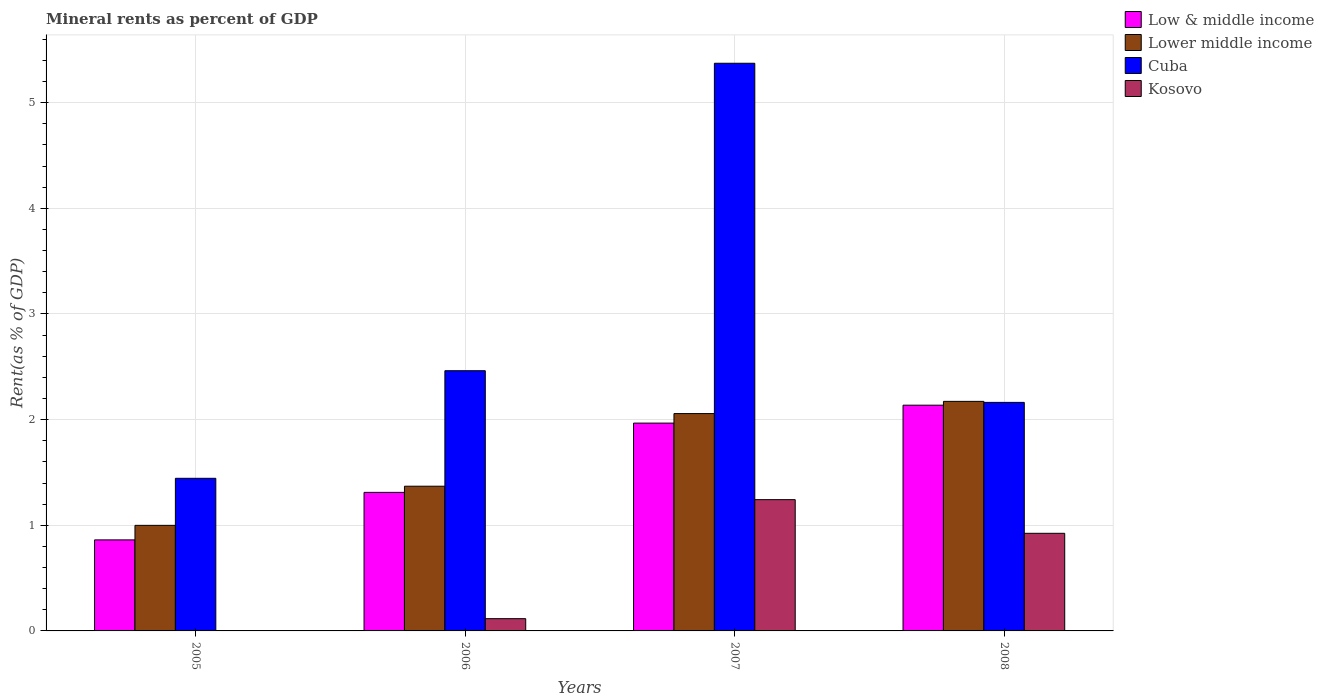How many different coloured bars are there?
Keep it short and to the point. 4. How many groups of bars are there?
Your response must be concise. 4. Are the number of bars per tick equal to the number of legend labels?
Provide a succinct answer. Yes. How many bars are there on the 3rd tick from the right?
Give a very brief answer. 4. What is the label of the 4th group of bars from the left?
Provide a succinct answer. 2008. What is the mineral rent in Lower middle income in 2008?
Keep it short and to the point. 2.17. Across all years, what is the maximum mineral rent in Low & middle income?
Keep it short and to the point. 2.14. Across all years, what is the minimum mineral rent in Low & middle income?
Offer a terse response. 0.86. In which year was the mineral rent in Low & middle income minimum?
Provide a succinct answer. 2005. What is the total mineral rent in Cuba in the graph?
Ensure brevity in your answer.  11.44. What is the difference between the mineral rent in Cuba in 2007 and that in 2008?
Give a very brief answer. 3.21. What is the difference between the mineral rent in Cuba in 2007 and the mineral rent in Lower middle income in 2006?
Offer a very short reply. 4. What is the average mineral rent in Kosovo per year?
Make the answer very short. 0.57. In the year 2006, what is the difference between the mineral rent in Lower middle income and mineral rent in Cuba?
Offer a terse response. -1.09. What is the ratio of the mineral rent in Kosovo in 2007 to that in 2008?
Offer a very short reply. 1.34. Is the mineral rent in Cuba in 2005 less than that in 2006?
Offer a terse response. Yes. What is the difference between the highest and the second highest mineral rent in Low & middle income?
Your answer should be very brief. 0.17. What is the difference between the highest and the lowest mineral rent in Low & middle income?
Your answer should be compact. 1.28. What does the 3rd bar from the left in 2005 represents?
Your answer should be very brief. Cuba. What does the 2nd bar from the right in 2006 represents?
Your answer should be very brief. Cuba. Are all the bars in the graph horizontal?
Ensure brevity in your answer.  No. What is the difference between two consecutive major ticks on the Y-axis?
Give a very brief answer. 1. Does the graph contain any zero values?
Your answer should be compact. No. Does the graph contain grids?
Keep it short and to the point. Yes. What is the title of the graph?
Offer a terse response. Mineral rents as percent of GDP. What is the label or title of the Y-axis?
Provide a succinct answer. Rent(as % of GDP). What is the Rent(as % of GDP) of Low & middle income in 2005?
Give a very brief answer. 0.86. What is the Rent(as % of GDP) of Lower middle income in 2005?
Make the answer very short. 1. What is the Rent(as % of GDP) in Cuba in 2005?
Keep it short and to the point. 1.44. What is the Rent(as % of GDP) of Kosovo in 2005?
Provide a succinct answer. 0. What is the Rent(as % of GDP) of Low & middle income in 2006?
Offer a very short reply. 1.31. What is the Rent(as % of GDP) in Lower middle income in 2006?
Ensure brevity in your answer.  1.37. What is the Rent(as % of GDP) in Cuba in 2006?
Offer a terse response. 2.46. What is the Rent(as % of GDP) in Kosovo in 2006?
Your answer should be compact. 0.12. What is the Rent(as % of GDP) of Low & middle income in 2007?
Keep it short and to the point. 1.97. What is the Rent(as % of GDP) of Lower middle income in 2007?
Make the answer very short. 2.06. What is the Rent(as % of GDP) of Cuba in 2007?
Provide a short and direct response. 5.37. What is the Rent(as % of GDP) of Kosovo in 2007?
Keep it short and to the point. 1.24. What is the Rent(as % of GDP) in Low & middle income in 2008?
Keep it short and to the point. 2.14. What is the Rent(as % of GDP) in Lower middle income in 2008?
Provide a succinct answer. 2.17. What is the Rent(as % of GDP) of Cuba in 2008?
Your answer should be very brief. 2.16. What is the Rent(as % of GDP) of Kosovo in 2008?
Make the answer very short. 0.92. Across all years, what is the maximum Rent(as % of GDP) in Low & middle income?
Your answer should be very brief. 2.14. Across all years, what is the maximum Rent(as % of GDP) in Lower middle income?
Your answer should be very brief. 2.17. Across all years, what is the maximum Rent(as % of GDP) of Cuba?
Provide a succinct answer. 5.37. Across all years, what is the maximum Rent(as % of GDP) of Kosovo?
Keep it short and to the point. 1.24. Across all years, what is the minimum Rent(as % of GDP) of Low & middle income?
Give a very brief answer. 0.86. Across all years, what is the minimum Rent(as % of GDP) of Lower middle income?
Your response must be concise. 1. Across all years, what is the minimum Rent(as % of GDP) in Cuba?
Offer a very short reply. 1.44. Across all years, what is the minimum Rent(as % of GDP) in Kosovo?
Make the answer very short. 0. What is the total Rent(as % of GDP) in Low & middle income in the graph?
Your answer should be very brief. 6.28. What is the total Rent(as % of GDP) in Lower middle income in the graph?
Make the answer very short. 6.6. What is the total Rent(as % of GDP) of Cuba in the graph?
Offer a terse response. 11.44. What is the total Rent(as % of GDP) of Kosovo in the graph?
Your answer should be very brief. 2.29. What is the difference between the Rent(as % of GDP) of Low & middle income in 2005 and that in 2006?
Ensure brevity in your answer.  -0.45. What is the difference between the Rent(as % of GDP) of Lower middle income in 2005 and that in 2006?
Offer a terse response. -0.37. What is the difference between the Rent(as % of GDP) in Cuba in 2005 and that in 2006?
Your response must be concise. -1.02. What is the difference between the Rent(as % of GDP) in Kosovo in 2005 and that in 2006?
Your answer should be very brief. -0.11. What is the difference between the Rent(as % of GDP) in Low & middle income in 2005 and that in 2007?
Ensure brevity in your answer.  -1.11. What is the difference between the Rent(as % of GDP) in Lower middle income in 2005 and that in 2007?
Give a very brief answer. -1.06. What is the difference between the Rent(as % of GDP) of Cuba in 2005 and that in 2007?
Provide a short and direct response. -3.93. What is the difference between the Rent(as % of GDP) in Kosovo in 2005 and that in 2007?
Ensure brevity in your answer.  -1.24. What is the difference between the Rent(as % of GDP) of Low & middle income in 2005 and that in 2008?
Your answer should be compact. -1.28. What is the difference between the Rent(as % of GDP) of Lower middle income in 2005 and that in 2008?
Ensure brevity in your answer.  -1.17. What is the difference between the Rent(as % of GDP) in Cuba in 2005 and that in 2008?
Offer a very short reply. -0.72. What is the difference between the Rent(as % of GDP) of Kosovo in 2005 and that in 2008?
Make the answer very short. -0.92. What is the difference between the Rent(as % of GDP) in Low & middle income in 2006 and that in 2007?
Give a very brief answer. -0.66. What is the difference between the Rent(as % of GDP) in Lower middle income in 2006 and that in 2007?
Your answer should be very brief. -0.69. What is the difference between the Rent(as % of GDP) in Cuba in 2006 and that in 2007?
Your answer should be compact. -2.91. What is the difference between the Rent(as % of GDP) in Kosovo in 2006 and that in 2007?
Offer a very short reply. -1.13. What is the difference between the Rent(as % of GDP) of Low & middle income in 2006 and that in 2008?
Your answer should be very brief. -0.83. What is the difference between the Rent(as % of GDP) in Lower middle income in 2006 and that in 2008?
Your answer should be compact. -0.8. What is the difference between the Rent(as % of GDP) in Cuba in 2006 and that in 2008?
Ensure brevity in your answer.  0.3. What is the difference between the Rent(as % of GDP) in Kosovo in 2006 and that in 2008?
Provide a succinct answer. -0.81. What is the difference between the Rent(as % of GDP) of Low & middle income in 2007 and that in 2008?
Ensure brevity in your answer.  -0.17. What is the difference between the Rent(as % of GDP) in Lower middle income in 2007 and that in 2008?
Your answer should be very brief. -0.12. What is the difference between the Rent(as % of GDP) of Cuba in 2007 and that in 2008?
Offer a terse response. 3.21. What is the difference between the Rent(as % of GDP) of Kosovo in 2007 and that in 2008?
Provide a succinct answer. 0.32. What is the difference between the Rent(as % of GDP) of Low & middle income in 2005 and the Rent(as % of GDP) of Lower middle income in 2006?
Provide a succinct answer. -0.51. What is the difference between the Rent(as % of GDP) in Low & middle income in 2005 and the Rent(as % of GDP) in Cuba in 2006?
Offer a very short reply. -1.6. What is the difference between the Rent(as % of GDP) of Low & middle income in 2005 and the Rent(as % of GDP) of Kosovo in 2006?
Give a very brief answer. 0.75. What is the difference between the Rent(as % of GDP) of Lower middle income in 2005 and the Rent(as % of GDP) of Cuba in 2006?
Ensure brevity in your answer.  -1.46. What is the difference between the Rent(as % of GDP) of Lower middle income in 2005 and the Rent(as % of GDP) of Kosovo in 2006?
Provide a short and direct response. 0.88. What is the difference between the Rent(as % of GDP) of Cuba in 2005 and the Rent(as % of GDP) of Kosovo in 2006?
Make the answer very short. 1.33. What is the difference between the Rent(as % of GDP) of Low & middle income in 2005 and the Rent(as % of GDP) of Lower middle income in 2007?
Give a very brief answer. -1.2. What is the difference between the Rent(as % of GDP) of Low & middle income in 2005 and the Rent(as % of GDP) of Cuba in 2007?
Give a very brief answer. -4.51. What is the difference between the Rent(as % of GDP) in Low & middle income in 2005 and the Rent(as % of GDP) in Kosovo in 2007?
Offer a very short reply. -0.38. What is the difference between the Rent(as % of GDP) of Lower middle income in 2005 and the Rent(as % of GDP) of Cuba in 2007?
Keep it short and to the point. -4.37. What is the difference between the Rent(as % of GDP) in Lower middle income in 2005 and the Rent(as % of GDP) in Kosovo in 2007?
Your answer should be compact. -0.24. What is the difference between the Rent(as % of GDP) in Cuba in 2005 and the Rent(as % of GDP) in Kosovo in 2007?
Give a very brief answer. 0.2. What is the difference between the Rent(as % of GDP) of Low & middle income in 2005 and the Rent(as % of GDP) of Lower middle income in 2008?
Provide a succinct answer. -1.31. What is the difference between the Rent(as % of GDP) of Low & middle income in 2005 and the Rent(as % of GDP) of Cuba in 2008?
Provide a succinct answer. -1.3. What is the difference between the Rent(as % of GDP) in Low & middle income in 2005 and the Rent(as % of GDP) in Kosovo in 2008?
Provide a short and direct response. -0.06. What is the difference between the Rent(as % of GDP) in Lower middle income in 2005 and the Rent(as % of GDP) in Cuba in 2008?
Your answer should be very brief. -1.16. What is the difference between the Rent(as % of GDP) of Lower middle income in 2005 and the Rent(as % of GDP) of Kosovo in 2008?
Provide a short and direct response. 0.08. What is the difference between the Rent(as % of GDP) of Cuba in 2005 and the Rent(as % of GDP) of Kosovo in 2008?
Keep it short and to the point. 0.52. What is the difference between the Rent(as % of GDP) of Low & middle income in 2006 and the Rent(as % of GDP) of Lower middle income in 2007?
Give a very brief answer. -0.75. What is the difference between the Rent(as % of GDP) of Low & middle income in 2006 and the Rent(as % of GDP) of Cuba in 2007?
Provide a short and direct response. -4.06. What is the difference between the Rent(as % of GDP) of Low & middle income in 2006 and the Rent(as % of GDP) of Kosovo in 2007?
Your answer should be compact. 0.07. What is the difference between the Rent(as % of GDP) of Lower middle income in 2006 and the Rent(as % of GDP) of Cuba in 2007?
Provide a short and direct response. -4. What is the difference between the Rent(as % of GDP) of Lower middle income in 2006 and the Rent(as % of GDP) of Kosovo in 2007?
Your response must be concise. 0.13. What is the difference between the Rent(as % of GDP) in Cuba in 2006 and the Rent(as % of GDP) in Kosovo in 2007?
Provide a succinct answer. 1.22. What is the difference between the Rent(as % of GDP) of Low & middle income in 2006 and the Rent(as % of GDP) of Lower middle income in 2008?
Offer a terse response. -0.86. What is the difference between the Rent(as % of GDP) of Low & middle income in 2006 and the Rent(as % of GDP) of Cuba in 2008?
Give a very brief answer. -0.85. What is the difference between the Rent(as % of GDP) in Low & middle income in 2006 and the Rent(as % of GDP) in Kosovo in 2008?
Your answer should be compact. 0.39. What is the difference between the Rent(as % of GDP) in Lower middle income in 2006 and the Rent(as % of GDP) in Cuba in 2008?
Your answer should be very brief. -0.79. What is the difference between the Rent(as % of GDP) of Lower middle income in 2006 and the Rent(as % of GDP) of Kosovo in 2008?
Your response must be concise. 0.45. What is the difference between the Rent(as % of GDP) in Cuba in 2006 and the Rent(as % of GDP) in Kosovo in 2008?
Your response must be concise. 1.54. What is the difference between the Rent(as % of GDP) in Low & middle income in 2007 and the Rent(as % of GDP) in Lower middle income in 2008?
Your answer should be very brief. -0.21. What is the difference between the Rent(as % of GDP) of Low & middle income in 2007 and the Rent(as % of GDP) of Cuba in 2008?
Provide a succinct answer. -0.2. What is the difference between the Rent(as % of GDP) in Low & middle income in 2007 and the Rent(as % of GDP) in Kosovo in 2008?
Provide a succinct answer. 1.04. What is the difference between the Rent(as % of GDP) in Lower middle income in 2007 and the Rent(as % of GDP) in Cuba in 2008?
Make the answer very short. -0.11. What is the difference between the Rent(as % of GDP) of Lower middle income in 2007 and the Rent(as % of GDP) of Kosovo in 2008?
Keep it short and to the point. 1.13. What is the difference between the Rent(as % of GDP) of Cuba in 2007 and the Rent(as % of GDP) of Kosovo in 2008?
Your answer should be very brief. 4.45. What is the average Rent(as % of GDP) in Low & middle income per year?
Offer a very short reply. 1.57. What is the average Rent(as % of GDP) in Lower middle income per year?
Keep it short and to the point. 1.65. What is the average Rent(as % of GDP) of Cuba per year?
Ensure brevity in your answer.  2.86. In the year 2005, what is the difference between the Rent(as % of GDP) in Low & middle income and Rent(as % of GDP) in Lower middle income?
Keep it short and to the point. -0.14. In the year 2005, what is the difference between the Rent(as % of GDP) of Low & middle income and Rent(as % of GDP) of Cuba?
Provide a succinct answer. -0.58. In the year 2005, what is the difference between the Rent(as % of GDP) of Low & middle income and Rent(as % of GDP) of Kosovo?
Offer a very short reply. 0.86. In the year 2005, what is the difference between the Rent(as % of GDP) of Lower middle income and Rent(as % of GDP) of Cuba?
Your answer should be very brief. -0.45. In the year 2005, what is the difference between the Rent(as % of GDP) of Lower middle income and Rent(as % of GDP) of Kosovo?
Make the answer very short. 1. In the year 2005, what is the difference between the Rent(as % of GDP) of Cuba and Rent(as % of GDP) of Kosovo?
Your answer should be compact. 1.44. In the year 2006, what is the difference between the Rent(as % of GDP) of Low & middle income and Rent(as % of GDP) of Lower middle income?
Offer a terse response. -0.06. In the year 2006, what is the difference between the Rent(as % of GDP) of Low & middle income and Rent(as % of GDP) of Cuba?
Give a very brief answer. -1.15. In the year 2006, what is the difference between the Rent(as % of GDP) of Low & middle income and Rent(as % of GDP) of Kosovo?
Keep it short and to the point. 1.2. In the year 2006, what is the difference between the Rent(as % of GDP) in Lower middle income and Rent(as % of GDP) in Cuba?
Your response must be concise. -1.09. In the year 2006, what is the difference between the Rent(as % of GDP) in Lower middle income and Rent(as % of GDP) in Kosovo?
Offer a terse response. 1.25. In the year 2006, what is the difference between the Rent(as % of GDP) in Cuba and Rent(as % of GDP) in Kosovo?
Give a very brief answer. 2.35. In the year 2007, what is the difference between the Rent(as % of GDP) of Low & middle income and Rent(as % of GDP) of Lower middle income?
Your response must be concise. -0.09. In the year 2007, what is the difference between the Rent(as % of GDP) of Low & middle income and Rent(as % of GDP) of Cuba?
Make the answer very short. -3.41. In the year 2007, what is the difference between the Rent(as % of GDP) of Low & middle income and Rent(as % of GDP) of Kosovo?
Ensure brevity in your answer.  0.72. In the year 2007, what is the difference between the Rent(as % of GDP) in Lower middle income and Rent(as % of GDP) in Cuba?
Your answer should be compact. -3.32. In the year 2007, what is the difference between the Rent(as % of GDP) of Lower middle income and Rent(as % of GDP) of Kosovo?
Your response must be concise. 0.81. In the year 2007, what is the difference between the Rent(as % of GDP) of Cuba and Rent(as % of GDP) of Kosovo?
Your answer should be compact. 4.13. In the year 2008, what is the difference between the Rent(as % of GDP) of Low & middle income and Rent(as % of GDP) of Lower middle income?
Keep it short and to the point. -0.04. In the year 2008, what is the difference between the Rent(as % of GDP) of Low & middle income and Rent(as % of GDP) of Cuba?
Your answer should be very brief. -0.03. In the year 2008, what is the difference between the Rent(as % of GDP) of Low & middle income and Rent(as % of GDP) of Kosovo?
Provide a short and direct response. 1.21. In the year 2008, what is the difference between the Rent(as % of GDP) in Lower middle income and Rent(as % of GDP) in Cuba?
Your response must be concise. 0.01. In the year 2008, what is the difference between the Rent(as % of GDP) in Lower middle income and Rent(as % of GDP) in Kosovo?
Give a very brief answer. 1.25. In the year 2008, what is the difference between the Rent(as % of GDP) of Cuba and Rent(as % of GDP) of Kosovo?
Keep it short and to the point. 1.24. What is the ratio of the Rent(as % of GDP) in Low & middle income in 2005 to that in 2006?
Offer a very short reply. 0.66. What is the ratio of the Rent(as % of GDP) of Lower middle income in 2005 to that in 2006?
Your response must be concise. 0.73. What is the ratio of the Rent(as % of GDP) in Cuba in 2005 to that in 2006?
Offer a very short reply. 0.59. What is the ratio of the Rent(as % of GDP) of Kosovo in 2005 to that in 2006?
Your answer should be very brief. 0.03. What is the ratio of the Rent(as % of GDP) of Low & middle income in 2005 to that in 2007?
Provide a succinct answer. 0.44. What is the ratio of the Rent(as % of GDP) of Lower middle income in 2005 to that in 2007?
Ensure brevity in your answer.  0.49. What is the ratio of the Rent(as % of GDP) in Cuba in 2005 to that in 2007?
Offer a terse response. 0.27. What is the ratio of the Rent(as % of GDP) in Kosovo in 2005 to that in 2007?
Make the answer very short. 0. What is the ratio of the Rent(as % of GDP) in Low & middle income in 2005 to that in 2008?
Your answer should be very brief. 0.4. What is the ratio of the Rent(as % of GDP) in Lower middle income in 2005 to that in 2008?
Provide a succinct answer. 0.46. What is the ratio of the Rent(as % of GDP) in Cuba in 2005 to that in 2008?
Give a very brief answer. 0.67. What is the ratio of the Rent(as % of GDP) of Kosovo in 2005 to that in 2008?
Provide a succinct answer. 0. What is the ratio of the Rent(as % of GDP) in Low & middle income in 2006 to that in 2007?
Offer a terse response. 0.67. What is the ratio of the Rent(as % of GDP) in Lower middle income in 2006 to that in 2007?
Provide a short and direct response. 0.67. What is the ratio of the Rent(as % of GDP) in Cuba in 2006 to that in 2007?
Offer a terse response. 0.46. What is the ratio of the Rent(as % of GDP) of Kosovo in 2006 to that in 2007?
Ensure brevity in your answer.  0.09. What is the ratio of the Rent(as % of GDP) of Low & middle income in 2006 to that in 2008?
Give a very brief answer. 0.61. What is the ratio of the Rent(as % of GDP) in Lower middle income in 2006 to that in 2008?
Give a very brief answer. 0.63. What is the ratio of the Rent(as % of GDP) in Cuba in 2006 to that in 2008?
Provide a succinct answer. 1.14. What is the ratio of the Rent(as % of GDP) in Kosovo in 2006 to that in 2008?
Your answer should be compact. 0.13. What is the ratio of the Rent(as % of GDP) in Low & middle income in 2007 to that in 2008?
Your response must be concise. 0.92. What is the ratio of the Rent(as % of GDP) of Lower middle income in 2007 to that in 2008?
Your answer should be very brief. 0.95. What is the ratio of the Rent(as % of GDP) of Cuba in 2007 to that in 2008?
Your answer should be compact. 2.48. What is the ratio of the Rent(as % of GDP) in Kosovo in 2007 to that in 2008?
Make the answer very short. 1.34. What is the difference between the highest and the second highest Rent(as % of GDP) in Low & middle income?
Provide a short and direct response. 0.17. What is the difference between the highest and the second highest Rent(as % of GDP) of Lower middle income?
Offer a terse response. 0.12. What is the difference between the highest and the second highest Rent(as % of GDP) of Cuba?
Your answer should be very brief. 2.91. What is the difference between the highest and the second highest Rent(as % of GDP) in Kosovo?
Make the answer very short. 0.32. What is the difference between the highest and the lowest Rent(as % of GDP) of Low & middle income?
Offer a very short reply. 1.28. What is the difference between the highest and the lowest Rent(as % of GDP) in Lower middle income?
Keep it short and to the point. 1.17. What is the difference between the highest and the lowest Rent(as % of GDP) in Cuba?
Your response must be concise. 3.93. What is the difference between the highest and the lowest Rent(as % of GDP) of Kosovo?
Your answer should be compact. 1.24. 